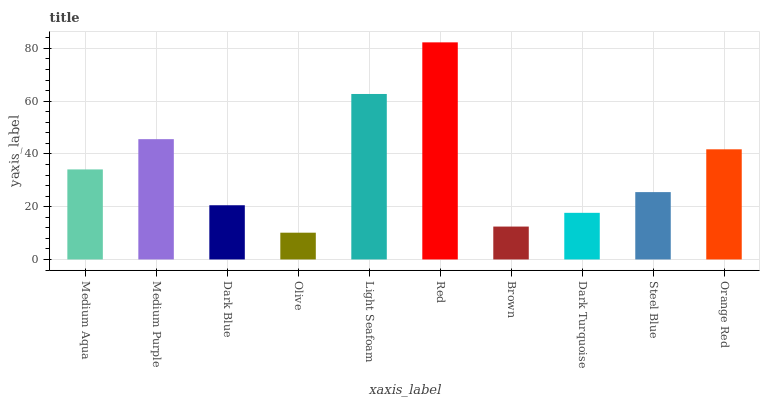Is Olive the minimum?
Answer yes or no. Yes. Is Red the maximum?
Answer yes or no. Yes. Is Medium Purple the minimum?
Answer yes or no. No. Is Medium Purple the maximum?
Answer yes or no. No. Is Medium Purple greater than Medium Aqua?
Answer yes or no. Yes. Is Medium Aqua less than Medium Purple?
Answer yes or no. Yes. Is Medium Aqua greater than Medium Purple?
Answer yes or no. No. Is Medium Purple less than Medium Aqua?
Answer yes or no. No. Is Medium Aqua the high median?
Answer yes or no. Yes. Is Steel Blue the low median?
Answer yes or no. Yes. Is Light Seafoam the high median?
Answer yes or no. No. Is Dark Blue the low median?
Answer yes or no. No. 